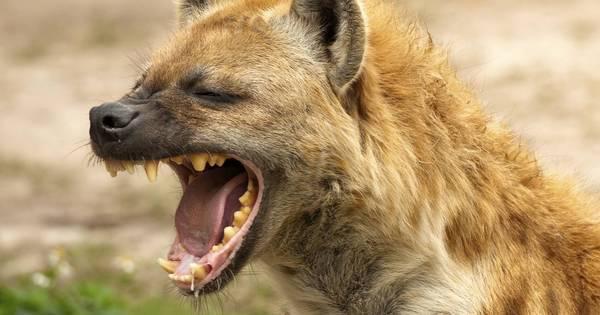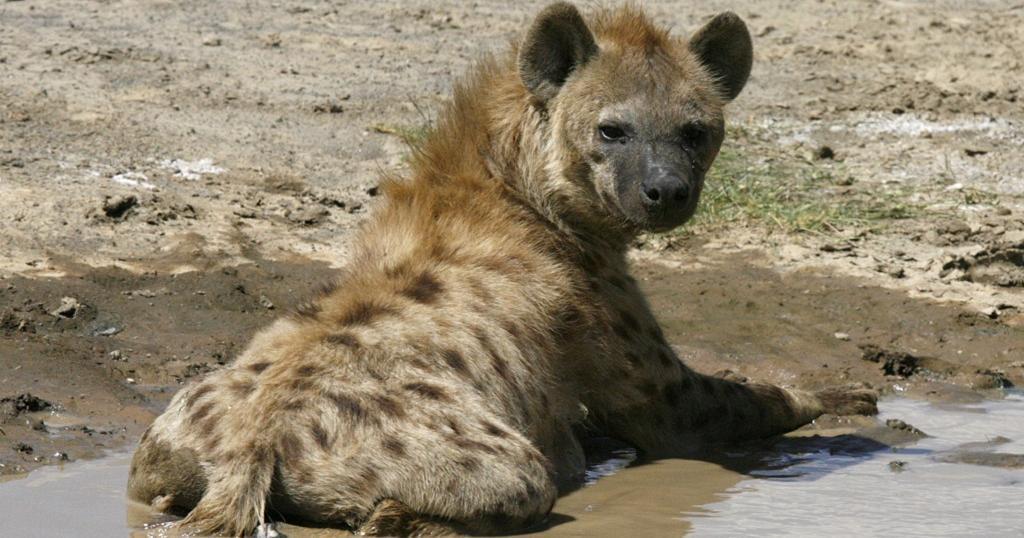The first image is the image on the left, the second image is the image on the right. Analyze the images presented: Is the assertion "There is a single hyena in each of the images." valid? Answer yes or no. Yes. 